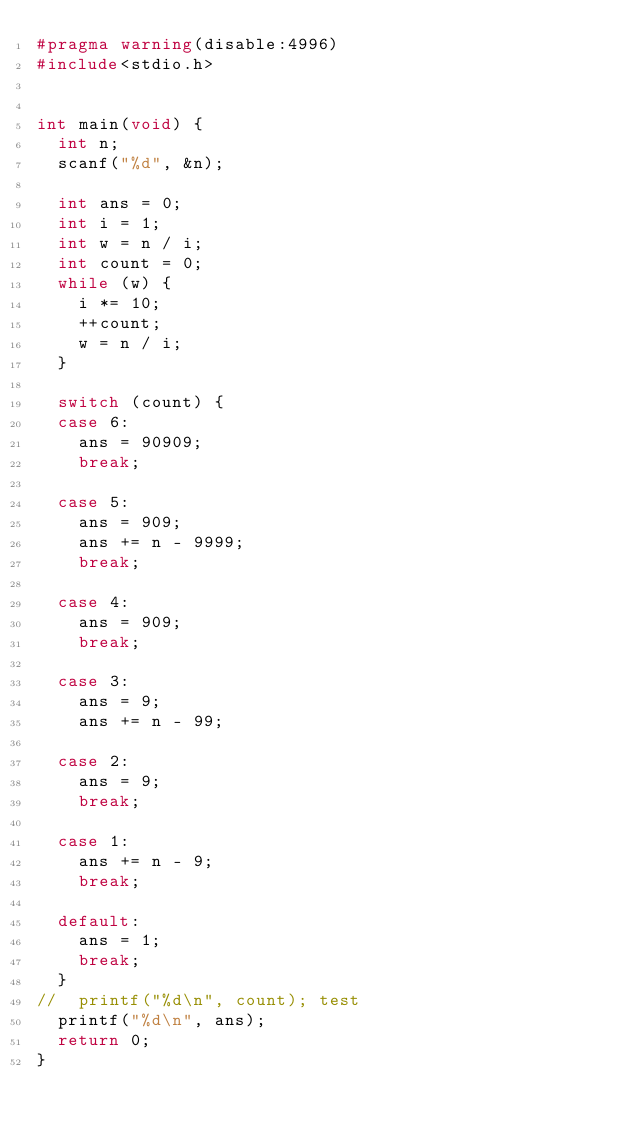<code> <loc_0><loc_0><loc_500><loc_500><_C_>#pragma warning(disable:4996)
#include<stdio.h>


int main(void) {
	int n;
	scanf("%d", &n);

	int ans = 0;
	int i = 1;
	int w = n / i;
	int count = 0;
	while (w) {
		i *= 10;
		++count;
		w = n / i;
	}

	switch (count) {
	case 6:
		ans = 90909;
		break;

	case 5:
		ans = 909;
		ans += n - 9999;
		break;

	case 4:
		ans = 909;
		break;

	case 3:
		ans = 9;
		ans += n - 99;

	case 2:
		ans = 9;
		break;

	case 1:
		ans += n - 9;
		break;

	default:
		ans = 1;
		break;
	}
//	printf("%d\n", count); test
	printf("%d\n", ans);
	return 0;
}</code> 